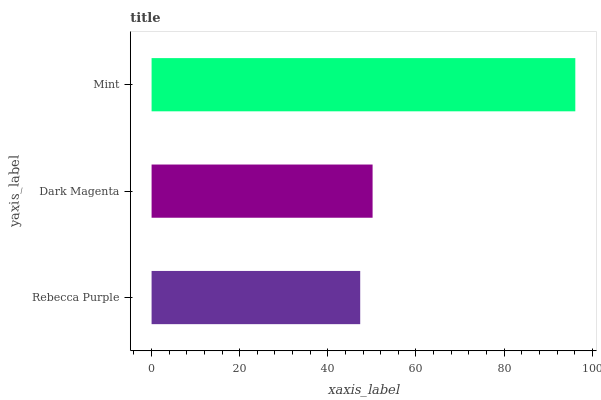Is Rebecca Purple the minimum?
Answer yes or no. Yes. Is Mint the maximum?
Answer yes or no. Yes. Is Dark Magenta the minimum?
Answer yes or no. No. Is Dark Magenta the maximum?
Answer yes or no. No. Is Dark Magenta greater than Rebecca Purple?
Answer yes or no. Yes. Is Rebecca Purple less than Dark Magenta?
Answer yes or no. Yes. Is Rebecca Purple greater than Dark Magenta?
Answer yes or no. No. Is Dark Magenta less than Rebecca Purple?
Answer yes or no. No. Is Dark Magenta the high median?
Answer yes or no. Yes. Is Dark Magenta the low median?
Answer yes or no. Yes. Is Mint the high median?
Answer yes or no. No. Is Mint the low median?
Answer yes or no. No. 